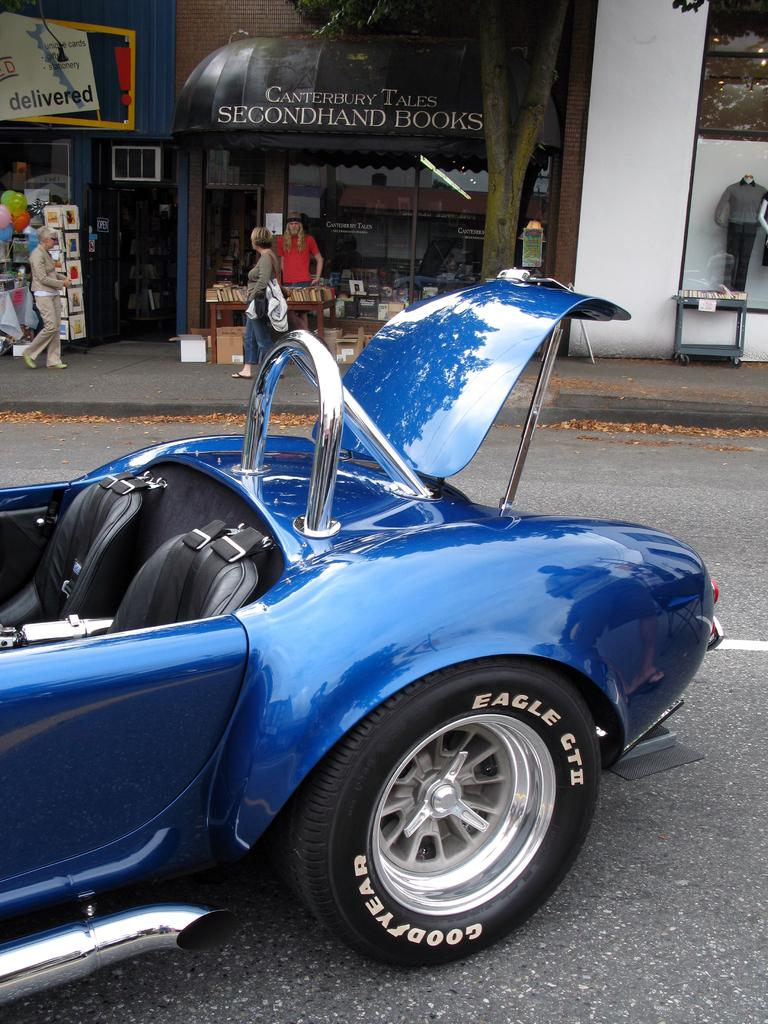What color is the vehicle in the image? The vehicle in the image is blue. Where is the vehicle located in the image? The vehicle is on the road. What can be seen in the background of the image? There are stores and people in the background of the image. How many cabbages are being used as hobbies by the people in the image? There is no mention of cabbages or hobbies in the image; it features a blue vehicle on the road with stores and people in the background. 